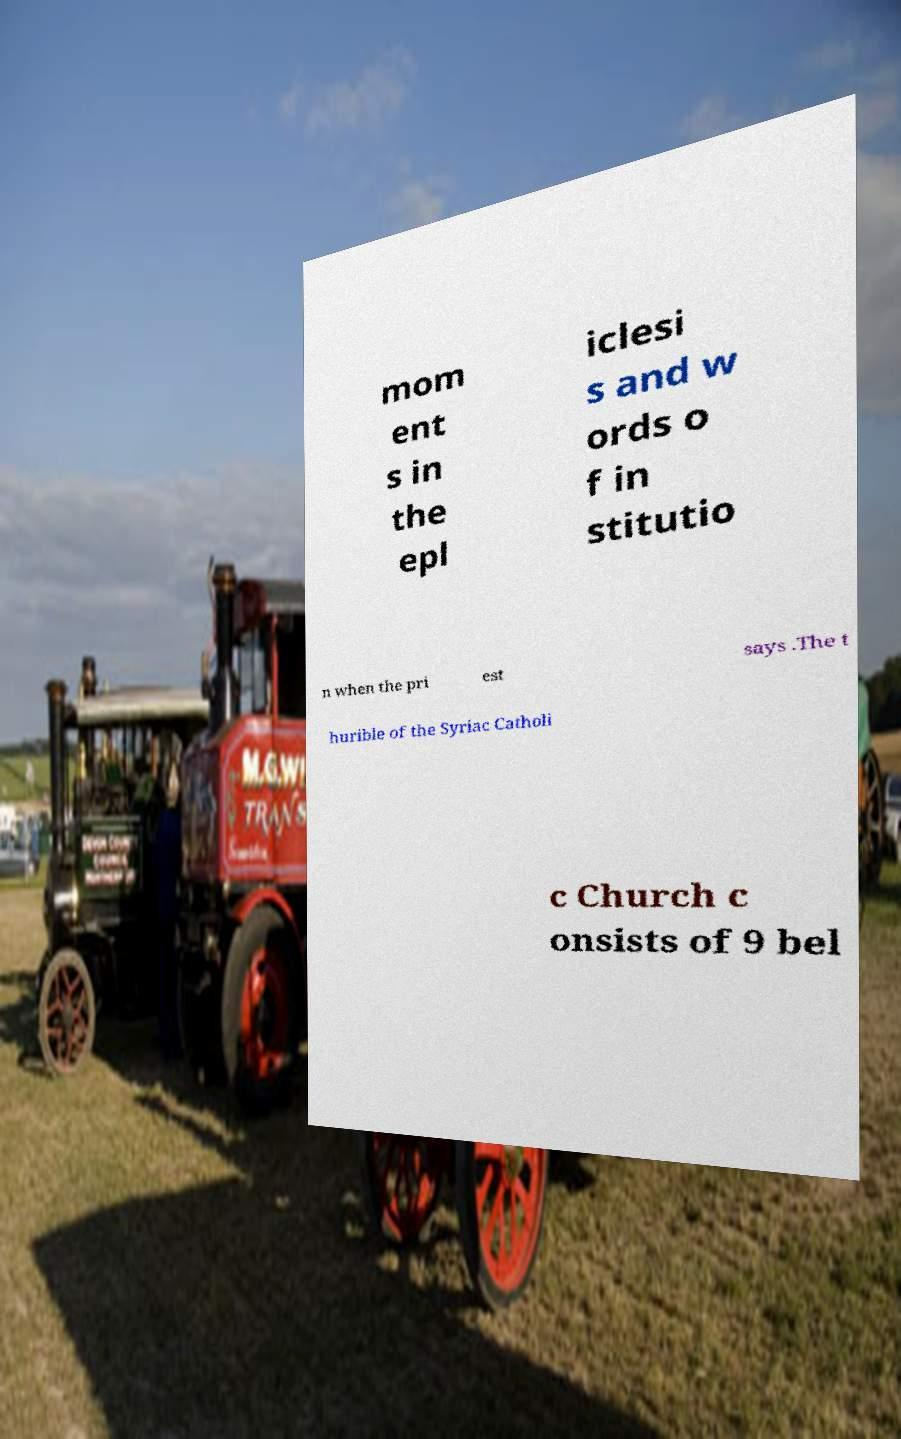Could you extract and type out the text from this image? mom ent s in the epl iclesi s and w ords o f in stitutio n when the pri est says .The t hurible of the Syriac Catholi c Church c onsists of 9 bel 